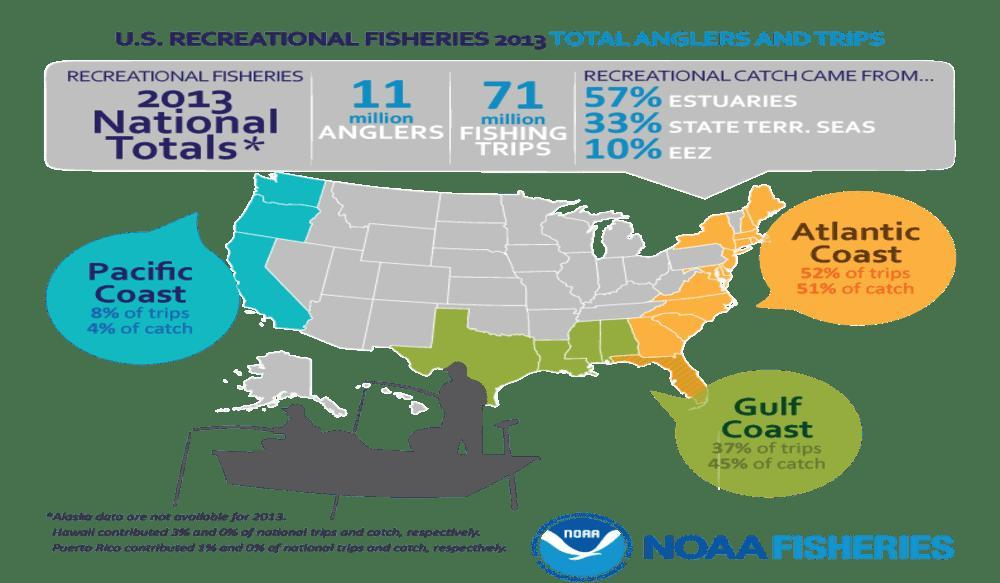Which coast in the U.S. had seen the most percent of catches as per the U.S. Recreational  Fisheries 2013 data?
Answer the question with a short phrase. Atlantic Coast Which coast in the U.S. had seen least percent of catches as per the U.S. Recreational  Fisheries 2013 data? Pacific Coast What percent of recreational catch came from estuaries as per the U.S. Recreational Fisheries 2013 survey? 57% What percent of catch were made in the Gulf coast as per the U.S. Recreational Fisheries 2013 data? 45% What is the total fishing trips done as per the U.S. Recreational Fisheries 2013 survey? 71 million What percent of trips were made in the Pacific coast as per the U.S. Recreational Fisheries 2013 data? 8% What is the total no of anglers as per the U.S. Recreational Fisheries 2013 data? 11 million What percent of trips were made in the atlantic coast as per the U.S. Recreational Fisheries 2013 data? 52% 